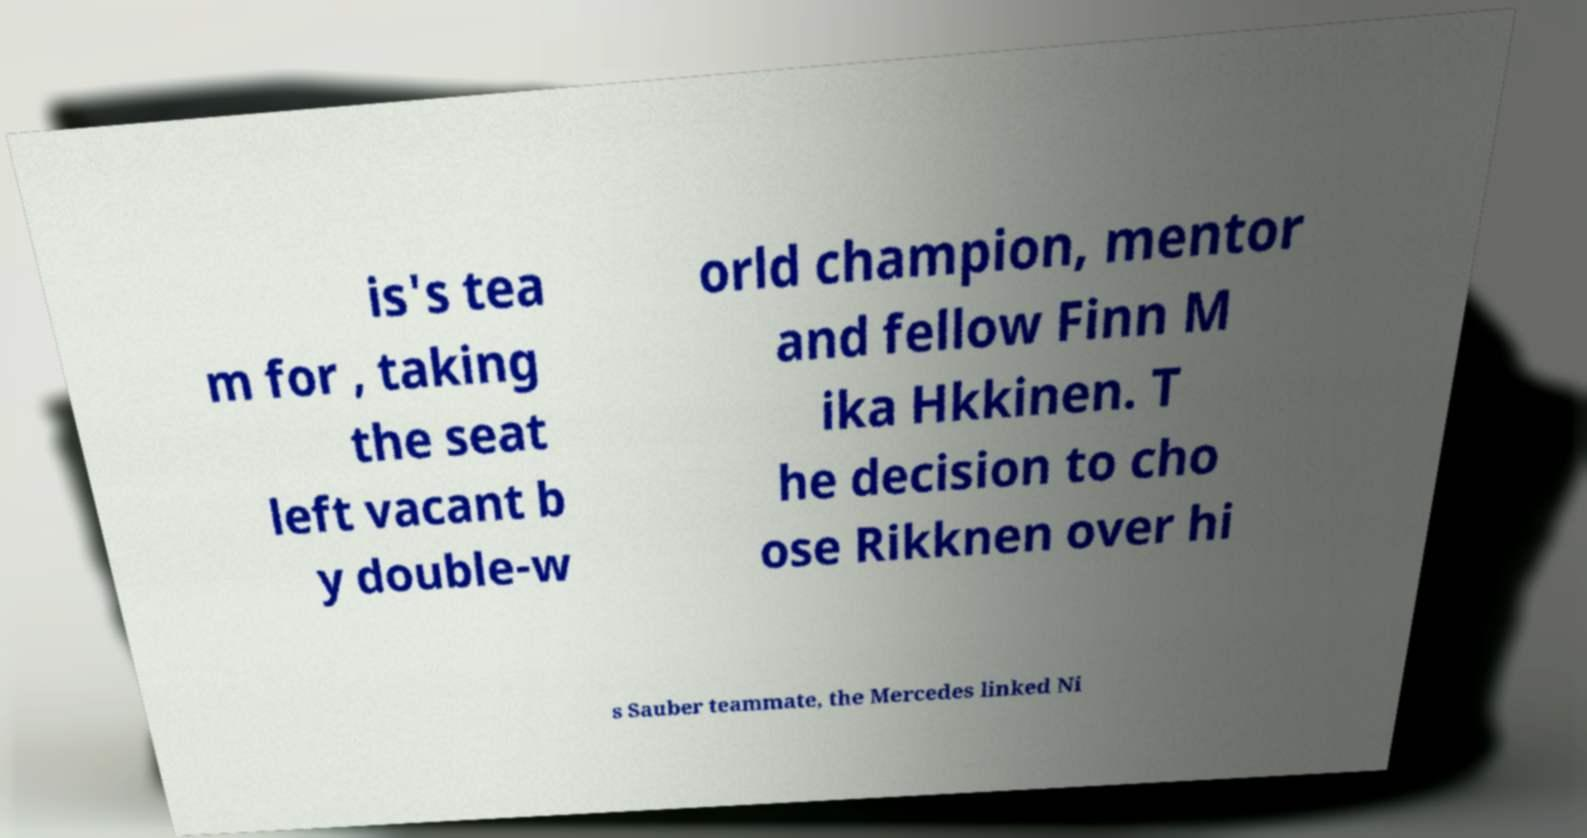Could you extract and type out the text from this image? is's tea m for , taking the seat left vacant b y double-w orld champion, mentor and fellow Finn M ika Hkkinen. T he decision to cho ose Rikknen over hi s Sauber teammate, the Mercedes linked Ni 